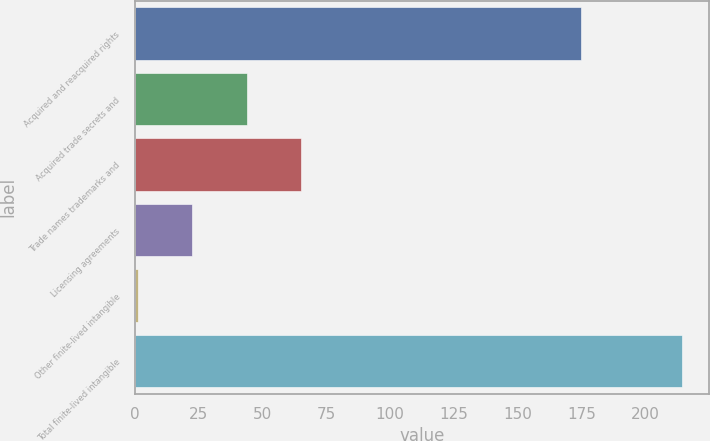Convert chart. <chart><loc_0><loc_0><loc_500><loc_500><bar_chart><fcel>Acquired and reacquired rights<fcel>Acquired trade secrets and<fcel>Trade names trademarks and<fcel>Licensing agreements<fcel>Other finite-lived intangible<fcel>Total finite-lived intangible<nl><fcel>174.6<fcel>43.8<fcel>65.1<fcel>22.5<fcel>1.2<fcel>214.2<nl></chart> 